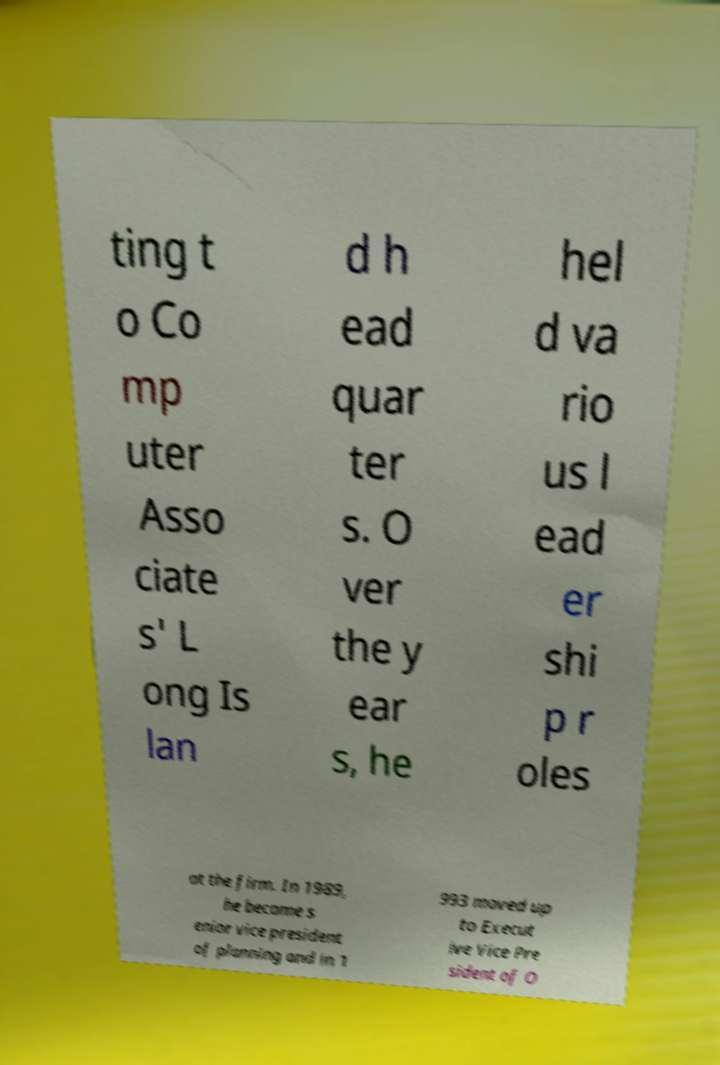Please read and relay the text visible in this image. What does it say? ting t o Co mp uter Asso ciate s' L ong Is lan d h ead quar ter s. O ver the y ear s, he hel d va rio us l ead er shi p r oles at the firm. In 1989, he became s enior vice president of planning and in 1 993 moved up to Execut ive Vice Pre sident of O 